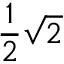Convert formula to latex. <formula><loc_0><loc_0><loc_500><loc_500>{ \frac { 1 } { 2 } } { \sqrt { 2 } }</formula> 